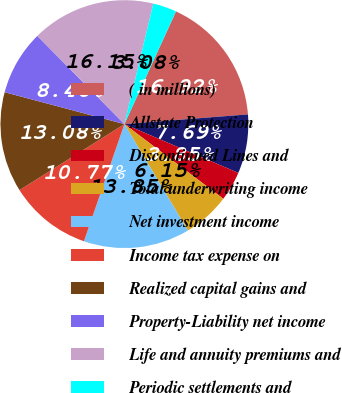<chart> <loc_0><loc_0><loc_500><loc_500><pie_chart><fcel>( in millions)<fcel>Allstate Protection<fcel>Discontinued Lines and<fcel>Total underwriting income<fcel>Net investment income<fcel>Income tax expense on<fcel>Realized capital gains and<fcel>Property-Liability net income<fcel>Life and annuity premiums and<fcel>Periodic settlements and<nl><fcel>16.92%<fcel>7.69%<fcel>3.85%<fcel>6.15%<fcel>13.85%<fcel>10.77%<fcel>13.08%<fcel>8.46%<fcel>16.15%<fcel>3.08%<nl></chart> 